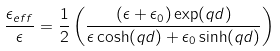Convert formula to latex. <formula><loc_0><loc_0><loc_500><loc_500>\frac { { \epsilon _ { e f f } } } { \epsilon } = \frac { 1 } { 2 } \left ( \frac { ( \epsilon + \epsilon _ { 0 } ) \exp ( q d ) } { \epsilon \cosh ( q d ) + \epsilon _ { 0 } \sinh ( q d ) } \right )</formula> 